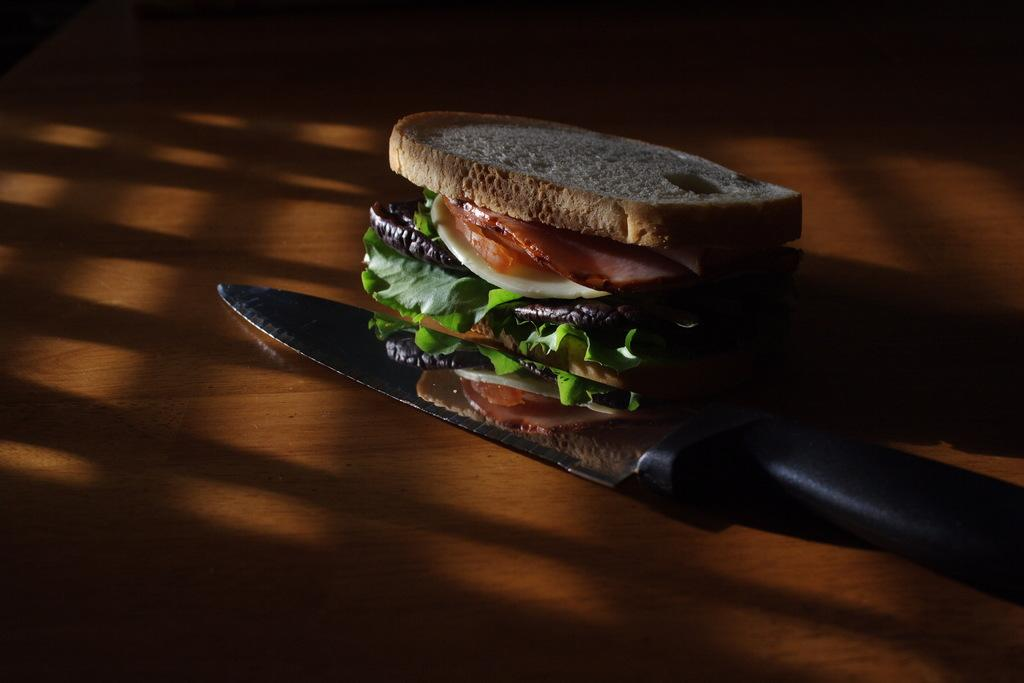What is the main object in the center of the image? There is a table in the center of the image. What can be found on the table? There is a knife and a sandwich on the table. What type of food is the sandwich made of? The sandwich contains bread, leafy vegetables, and other food items. What type of chain can be seen connecting the sandwich and the knife in the image? There is no chain present in the image connecting the sandwich and the knife. 